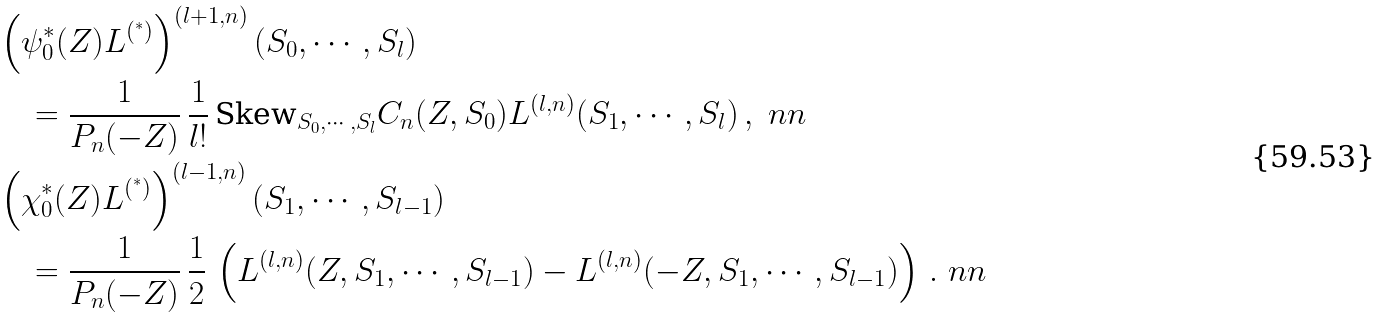<formula> <loc_0><loc_0><loc_500><loc_500>& \left ( \psi _ { 0 } ^ { * } ( Z ) L ^ { ( ^ { * } ) } \right ) ^ { ( l + 1 , n ) } ( S _ { 0 } , \cdots , S _ { l } ) \\ & \quad = \frac { 1 } { P _ { n } ( - Z ) } \, \frac { 1 } { l ! } \, \text {Skew} _ { S _ { 0 } , \cdots , S _ { l } } C _ { n } ( Z , S _ { 0 } ) L ^ { ( l , n ) } ( S _ { 1 } , \cdots , S _ { l } ) \, , \ n n \\ & \left ( \chi _ { 0 } ^ { * } ( Z ) L ^ { ( ^ { * } ) } \right ) ^ { ( l - 1 , n ) } ( S _ { 1 } , \cdots , S _ { l - 1 } ) \\ & \quad = \frac { 1 } { P _ { n } ( - Z ) } \, \frac { 1 } { 2 } \, \left ( L ^ { ( l , n ) } ( Z , S _ { 1 } , \cdots , S _ { l - 1 } ) - L ^ { ( l , n ) } ( - Z , S _ { 1 } , \cdots , S _ { l - 1 } ) \right ) \, . \ n n</formula> 